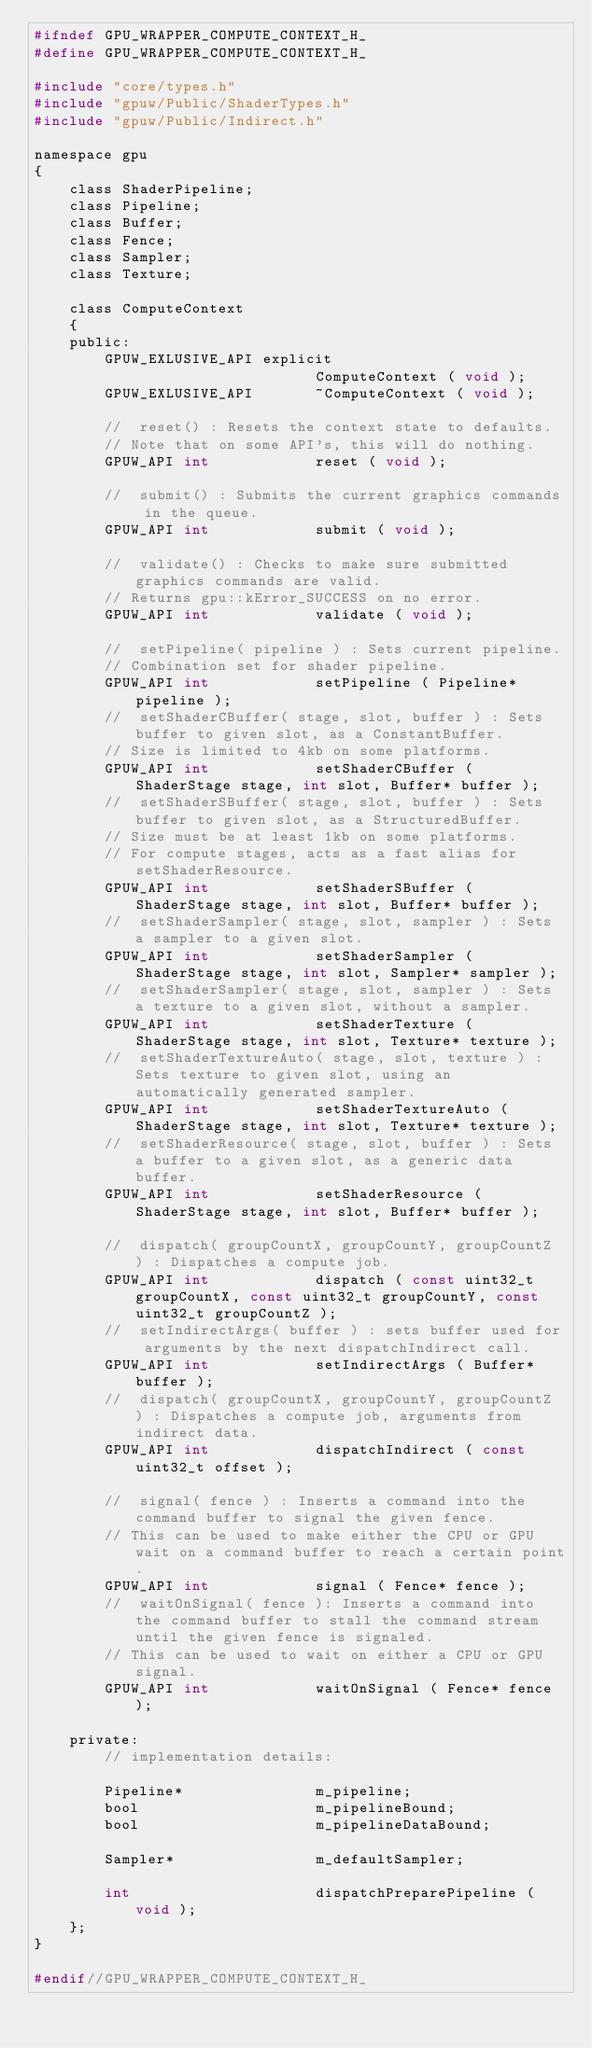Convert code to text. <code><loc_0><loc_0><loc_500><loc_500><_C_>#ifndef GPU_WRAPPER_COMPUTE_CONTEXT_H_
#define GPU_WRAPPER_COMPUTE_CONTEXT_H_

#include "core/types.h"
#include "gpuw/Public/ShaderTypes.h"
#include "gpuw/Public/Indirect.h"

namespace gpu
{
	class ShaderPipeline;
	class Pipeline;
	class Buffer;
	class Fence;
	class Sampler;
	class Texture;

	class ComputeContext
	{
	public:
		GPUW_EXLUSIVE_API explicit
								ComputeContext ( void );
		GPUW_EXLUSIVE_API 		~ComputeContext ( void );

		//	reset() : Resets the context state to defaults.
		// Note that on some API's, this will do nothing.
		GPUW_API int			reset ( void );

		//	submit() : Submits the current graphics commands in the queue.
		GPUW_API int			submit ( void );

		//	validate() : Checks to make sure submitted graphics commands are valid.
		// Returns gpu::kError_SUCCESS on no error.
		GPUW_API int			validate ( void );

		//	setPipeline( pipeline ) : Sets current pipeline.
		// Combination set for shader pipeline.
		GPUW_API int			setPipeline ( Pipeline* pipeline );
		//	setShaderCBuffer( stage, slot, buffer ) : Sets buffer to given slot, as a ConstantBuffer.
		// Size is limited to 4kb on some platforms.
		GPUW_API int			setShaderCBuffer ( ShaderStage stage, int slot, Buffer* buffer );
		//	setShaderSBuffer( stage, slot, buffer ) : Sets buffer to given slot, as a StructuredBuffer.
		// Size must be at least 1kb on some platforms.
		// For compute stages, acts as a fast alias for setShaderResource.
		GPUW_API int			setShaderSBuffer ( ShaderStage stage, int slot, Buffer* buffer );
		//	setShaderSampler( stage, slot, sampler ) : Sets a sampler to a given slot.
		GPUW_API int			setShaderSampler ( ShaderStage stage, int slot, Sampler* sampler );
		//	setShaderSampler( stage, slot, sampler ) : Sets a texture to a given slot, without a sampler.
		GPUW_API int			setShaderTexture ( ShaderStage stage, int slot, Texture* texture );
		//	setShaderTextureAuto( stage, slot, texture ) : Sets texture to given slot, using an automatically generated sampler.
		GPUW_API int			setShaderTextureAuto ( ShaderStage stage, int slot, Texture* texture );
		//	setShaderResource( stage, slot, buffer ) : Sets a buffer to a given slot, as a generic data buffer.
		GPUW_API int			setShaderResource ( ShaderStage stage, int slot, Buffer* buffer );

		//	dispatch( groupCountX, groupCountY, groupCountZ ) : Dispatches a compute job.
		GPUW_API int			dispatch ( const uint32_t groupCountX, const uint32_t groupCountY, const uint32_t groupCountZ );
		//	setIndirectArgs( buffer ) : sets buffer used for arguments by the next dispatchIndirect call.
		GPUW_API int			setIndirectArgs ( Buffer* buffer );
		//	dispatch( groupCountX, groupCountY, groupCountZ ) : Dispatches a compute job, arguments from indirect data.
		GPUW_API int			dispatchIndirect ( const uint32_t offset );

		//	signal( fence ) : Inserts a command into the command buffer to signal the given fence.
		// This can be used to make either the CPU or GPU wait on a command buffer to reach a certain point.
		GPUW_API int			signal ( Fence* fence );
		//	waitOnSignal( fence ): Inserts a command into the command buffer to stall the command stream until the given fence is signaled.
		// This can be used to wait on either a CPU or GPU signal.
		GPUW_API int			waitOnSignal ( Fence* fence );

	private:
		// implementation details:

		Pipeline*				m_pipeline;
		bool					m_pipelineBound;
		bool					m_pipelineDataBound;

		Sampler*				m_defaultSampler;

		int						dispatchPreparePipeline ( void );
	};
}

#endif//GPU_WRAPPER_COMPUTE_CONTEXT_H_</code> 